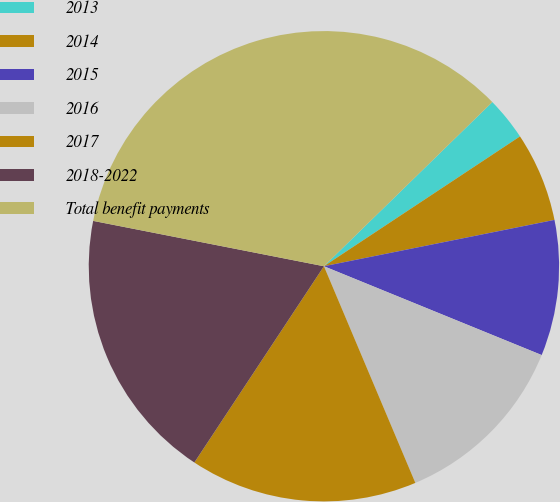Convert chart. <chart><loc_0><loc_0><loc_500><loc_500><pie_chart><fcel>2013<fcel>2014<fcel>2015<fcel>2016<fcel>2017<fcel>2018-2022<fcel>Total benefit payments<nl><fcel>2.99%<fcel>6.15%<fcel>9.32%<fcel>12.48%<fcel>15.64%<fcel>18.8%<fcel>34.61%<nl></chart> 